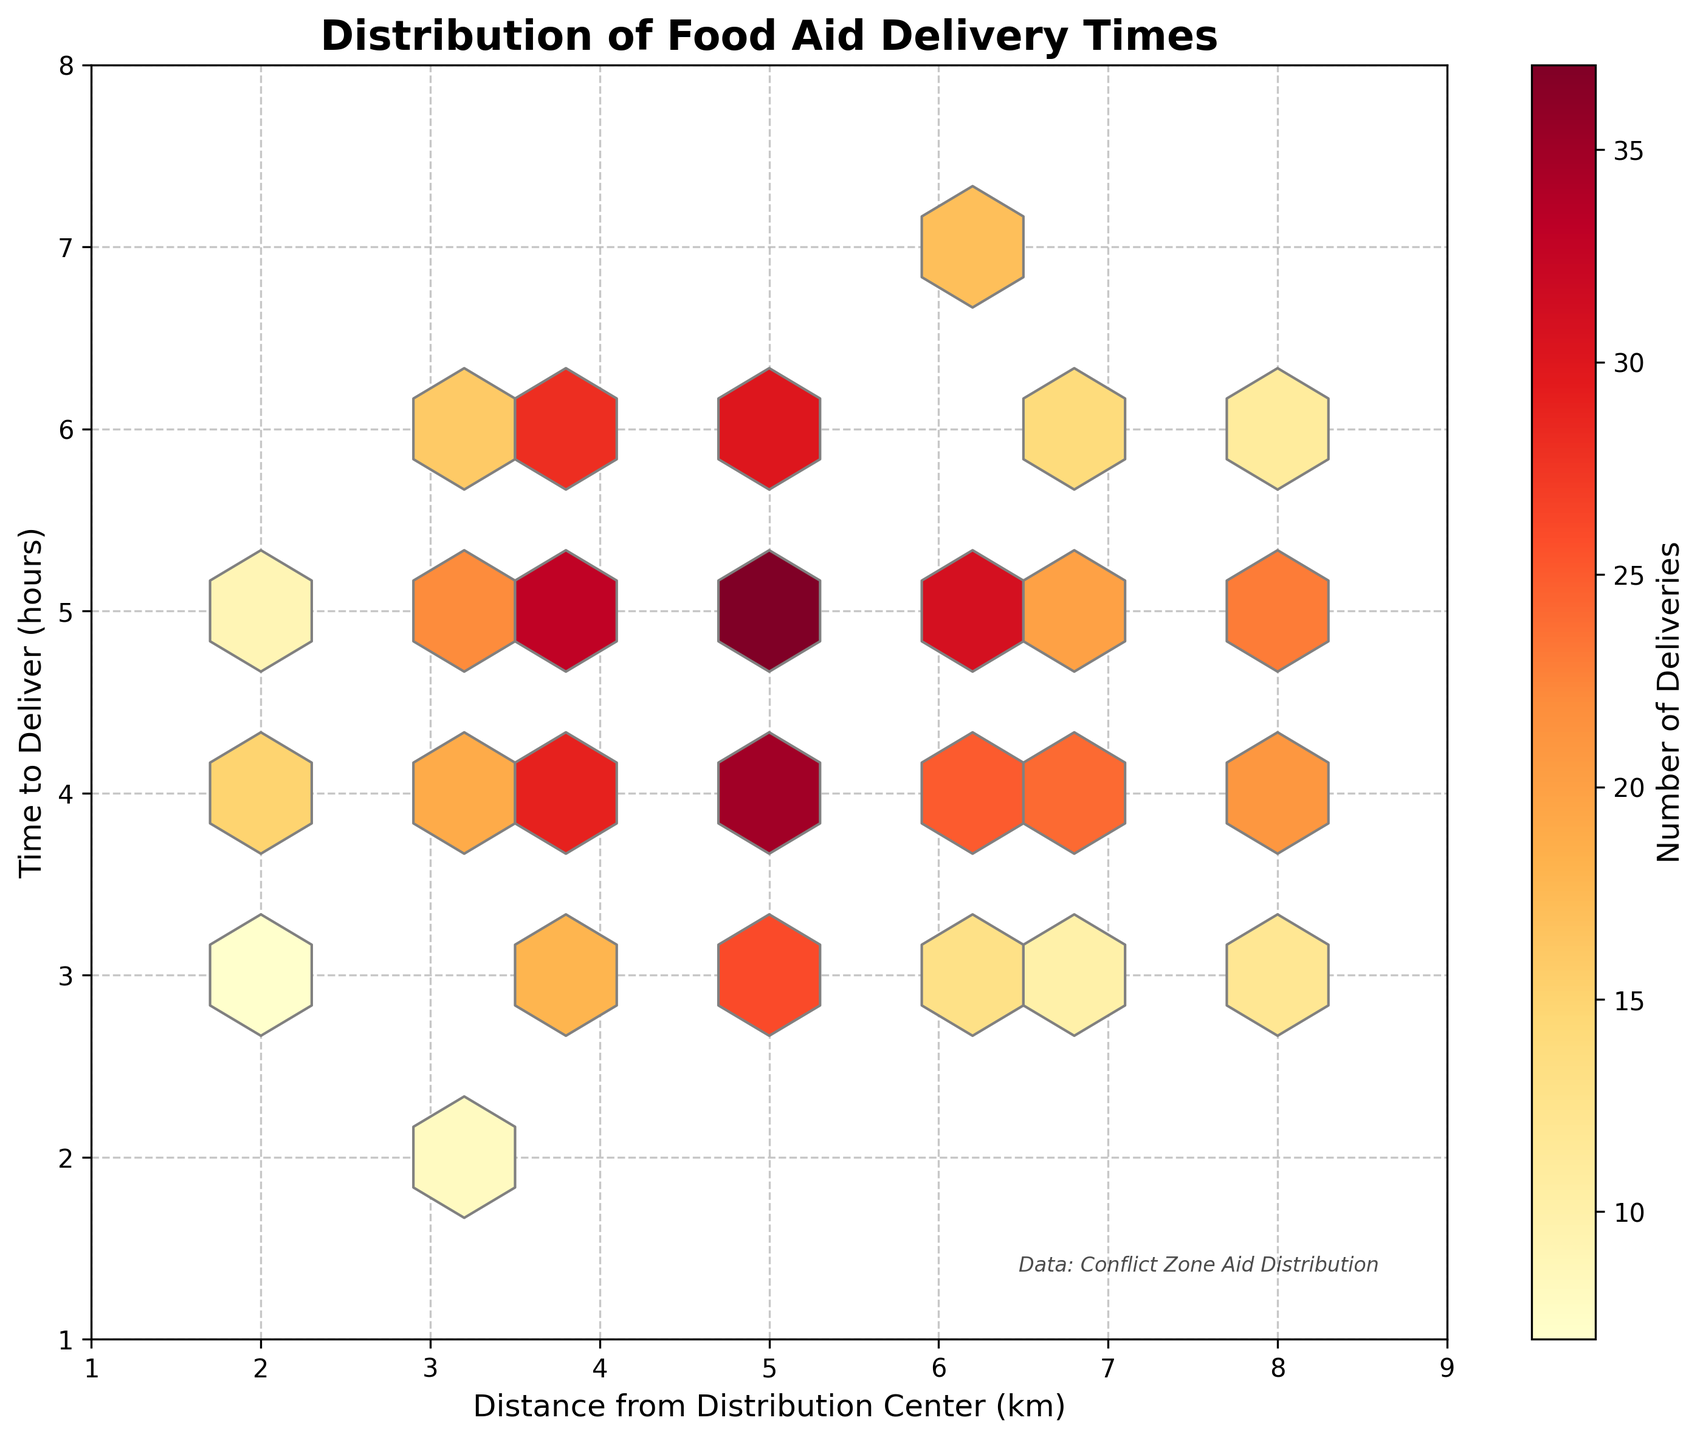What is the title of the plot? The title is usually positioned at the top of the plot. The title of this plot is in bold and larger font size compared to other text.
Answer: Distribution of Food Aid Delivery Times What do the colors in the hexagonal bins represent? The color gradient in a hexbin plot indicates the intensity or number of data points in each bin. In this case, the gradient from light yellow to dark red shows the number of deliveries.
Answer: Number of Deliveries What are the axes labeled in this plot? The x-axis and y-axis labels provide context for the data being visualized. The labels are directly next to or below the respective axis.
Answer: Distance from Distribution Center (km) and Time to Deliver (hours) Which hexagon shows the maximum number of deliveries? By looking at the color gradient and identifying the darkest hexagon on the plot, we can determine the bin with the most deliveries. The color legend on the right further assists in confirming this value.
Answer: The hexagon at (5, 5) How many bins show more than 30 deliveries? To answer this, count the number of hexagons that are shaded in the color range representing more than 30 deliveries, as indicated by the color bar.
Answer: 4 Which hexagon has the highest number of deliveries for a timeframe greater than 5 hours? Identify hexagons where the y-axis value (Time to Deliver) is greater than 5 hours and check the color intensity within that range to find the maximum.
Answer: The hexagon at (5, 6) What's the approximate number of deliveries at a distance of 4 km and a delivery time of 5 hours? Locate the hexagon at the coordinates (4, 5), then refer to its color and the color bar to estimate the number of deliveries.
Answer: 33 Are there more deliveries for distances 6 km and above or below 6 km? Sum the deliveries of hexagons with x-values less than 6 and compare them to the sum for x-values 6 and above to determine the higher total.
Answer: Below 6 km How does the delivery count change as we move from (2,4) to (8,4)? Track the color changes across hexagons along the y-axis value of 4 from x = 2 to x = 8 and note the trend.
Answer: It generally increases How many hexagons represent distances between 2 and 8 km and delivery times between 3 and 6 hours? Count the hexagons bounded by the x-axis range of 2–8 km and y-axis range of 3-6 hours, regardless of color intensity.
Answer: 16 